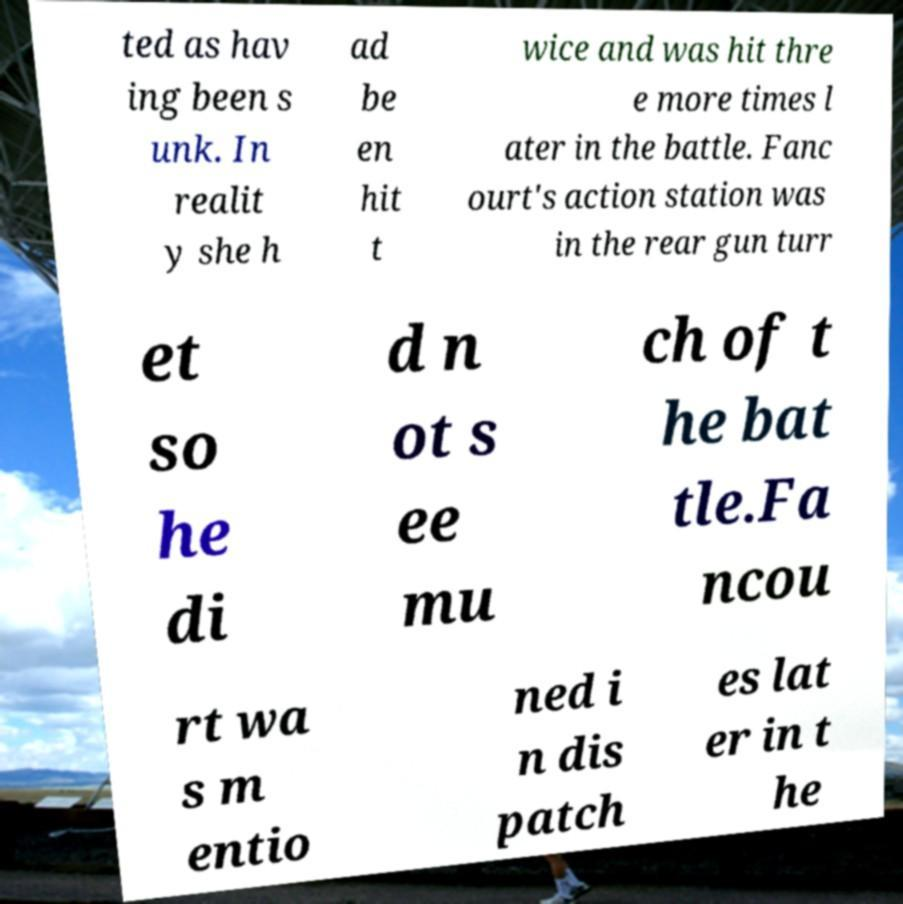Please read and relay the text visible in this image. What does it say? ted as hav ing been s unk. In realit y she h ad be en hit t wice and was hit thre e more times l ater in the battle. Fanc ourt's action station was in the rear gun turr et so he di d n ot s ee mu ch of t he bat tle.Fa ncou rt wa s m entio ned i n dis patch es lat er in t he 